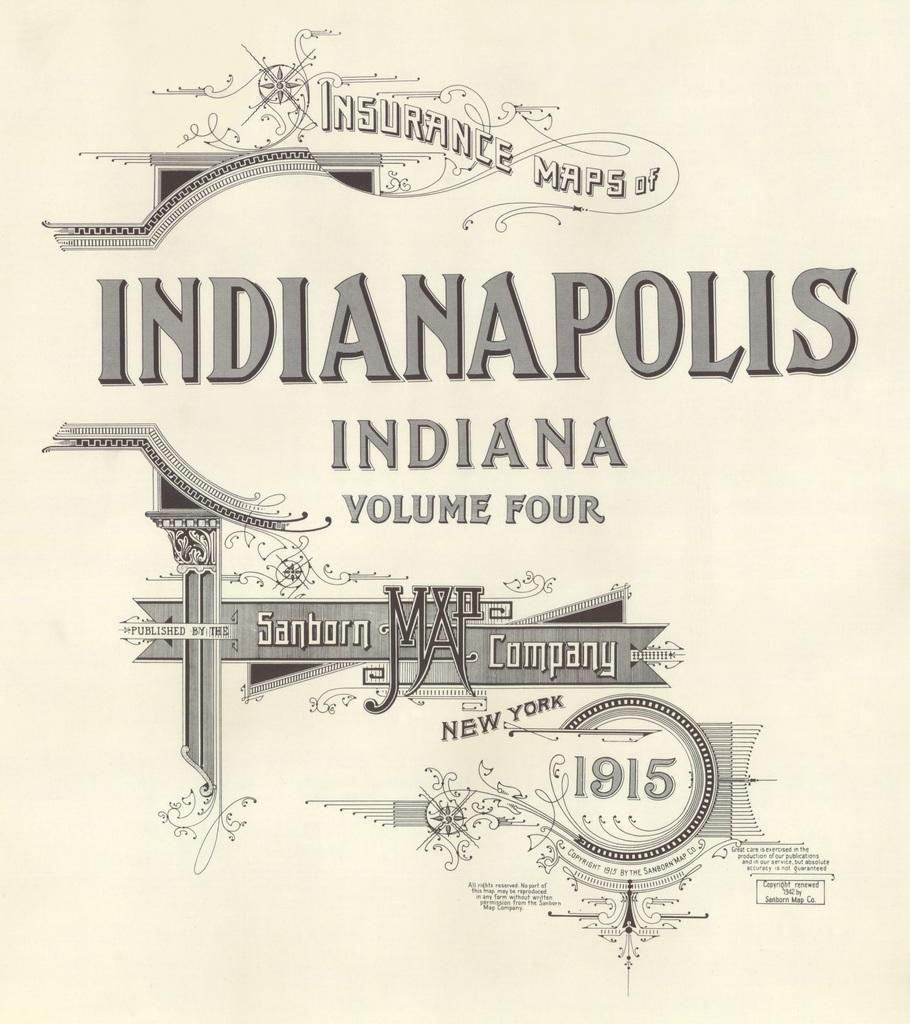<image>
Create a compact narrative representing the image presented. An book of maps of Indianapolis from 1915. 